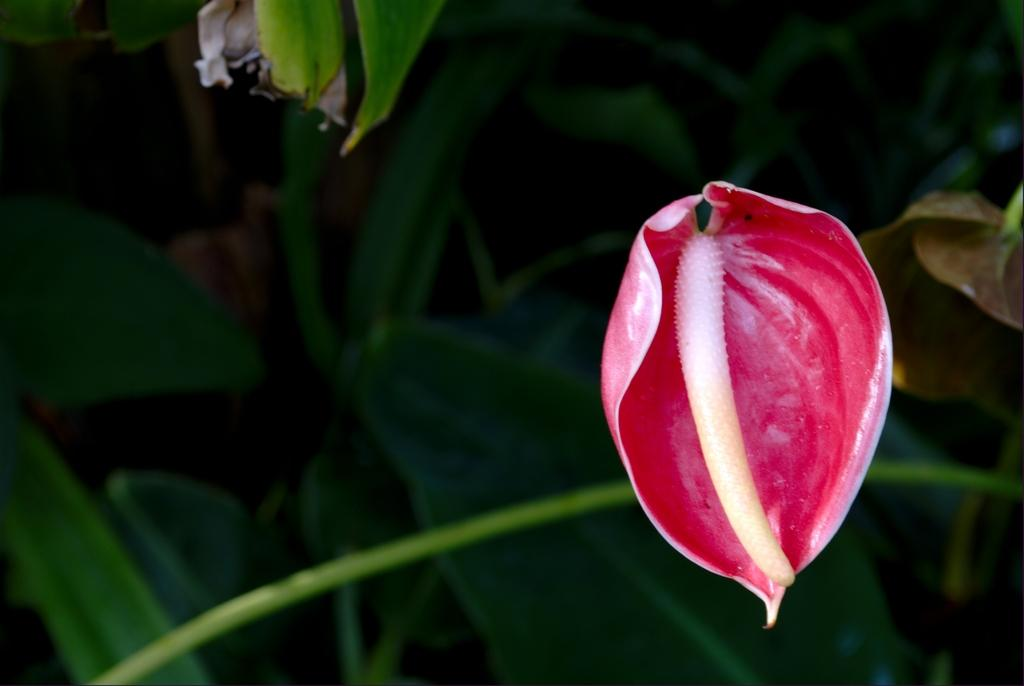What is the main subject of the image? There is a flower in the image. Can you describe the flower's position in the image? The flower is on the stem of a plant. What else can be seen in the background of the image? There are leaves visible in the background of the image. What type of curtain is hanging from the flower in the image? There is no curtain present in the image; it features a flower on the stem of a plant with leaves in the background. 